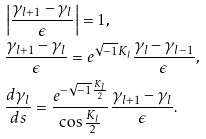<formula> <loc_0><loc_0><loc_500><loc_500>& \left | \frac { \gamma _ { l + 1 } - \gamma _ { l } } { \epsilon } \right | = 1 , \\ & \frac { \gamma _ { l + 1 } - \gamma _ { l } } { \epsilon } = e ^ { \sqrt { - 1 } K _ { l } } \frac { \gamma _ { l } - \gamma _ { l - 1 } } { \epsilon } , \\ & \frac { d \gamma _ { l } } { d s } = \frac { e ^ { - \sqrt { - 1 } \frac { K _ { l } } { 2 } } } { \cos \frac { K _ { l } } { 2 } } \frac { \gamma _ { l + 1 } - \gamma _ { l } } { \epsilon } .</formula> 